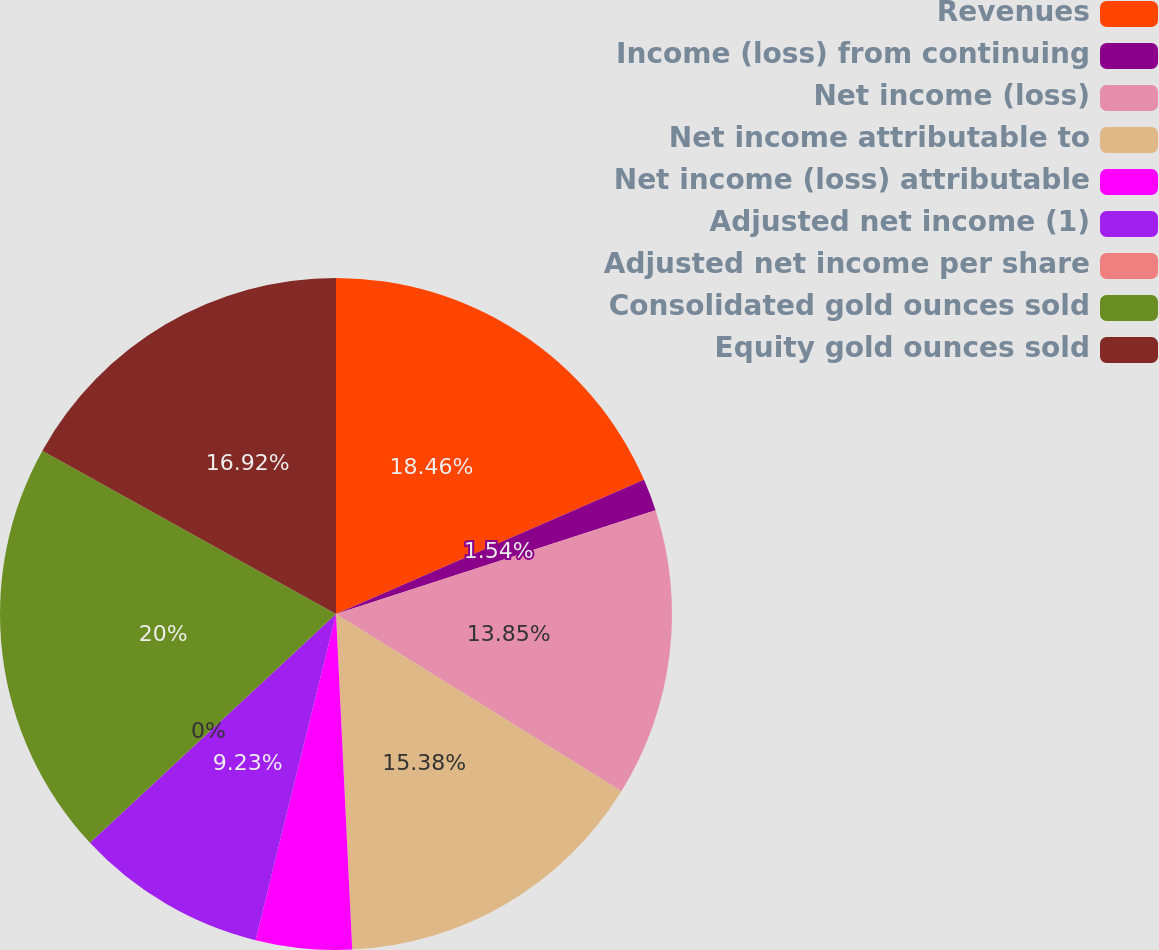Convert chart. <chart><loc_0><loc_0><loc_500><loc_500><pie_chart><fcel>Revenues<fcel>Income (loss) from continuing<fcel>Net income (loss)<fcel>Net income attributable to<fcel>Net income (loss) attributable<fcel>Adjusted net income (1)<fcel>Adjusted net income per share<fcel>Consolidated gold ounces sold<fcel>Equity gold ounces sold<nl><fcel>18.46%<fcel>1.54%<fcel>13.85%<fcel>15.38%<fcel>4.62%<fcel>9.23%<fcel>0.0%<fcel>20.0%<fcel>16.92%<nl></chart> 